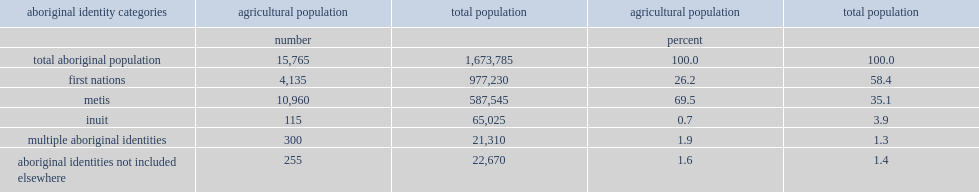Which group of people is the largest group of aboriginal people living in agricultural household in 2016? Metis. What percentage of the agriculture popluation can metis account for? 69.5. How many first nations people were part of the agricultural population. 4135.0. How many inuit were part of the agricultural population? 115.0. 